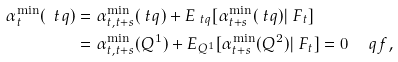<formula> <loc_0><loc_0><loc_500><loc_500>\alpha _ { t } ^ { \min } ( \ t q ) & = \alpha _ { t , t + s } ^ { \min } ( \ t q ) + E _ { \ t q } [ \alpha _ { t + s } ^ { \min } ( \ t q ) | \ F _ { t } ] \\ & = \alpha _ { t , t + s } ^ { \min } ( Q ^ { 1 } ) + E _ { Q ^ { 1 } } [ \alpha _ { t + s } ^ { \min } ( Q ^ { 2 } ) | \ F _ { t } ] = 0 \quad \ q f ,</formula> 